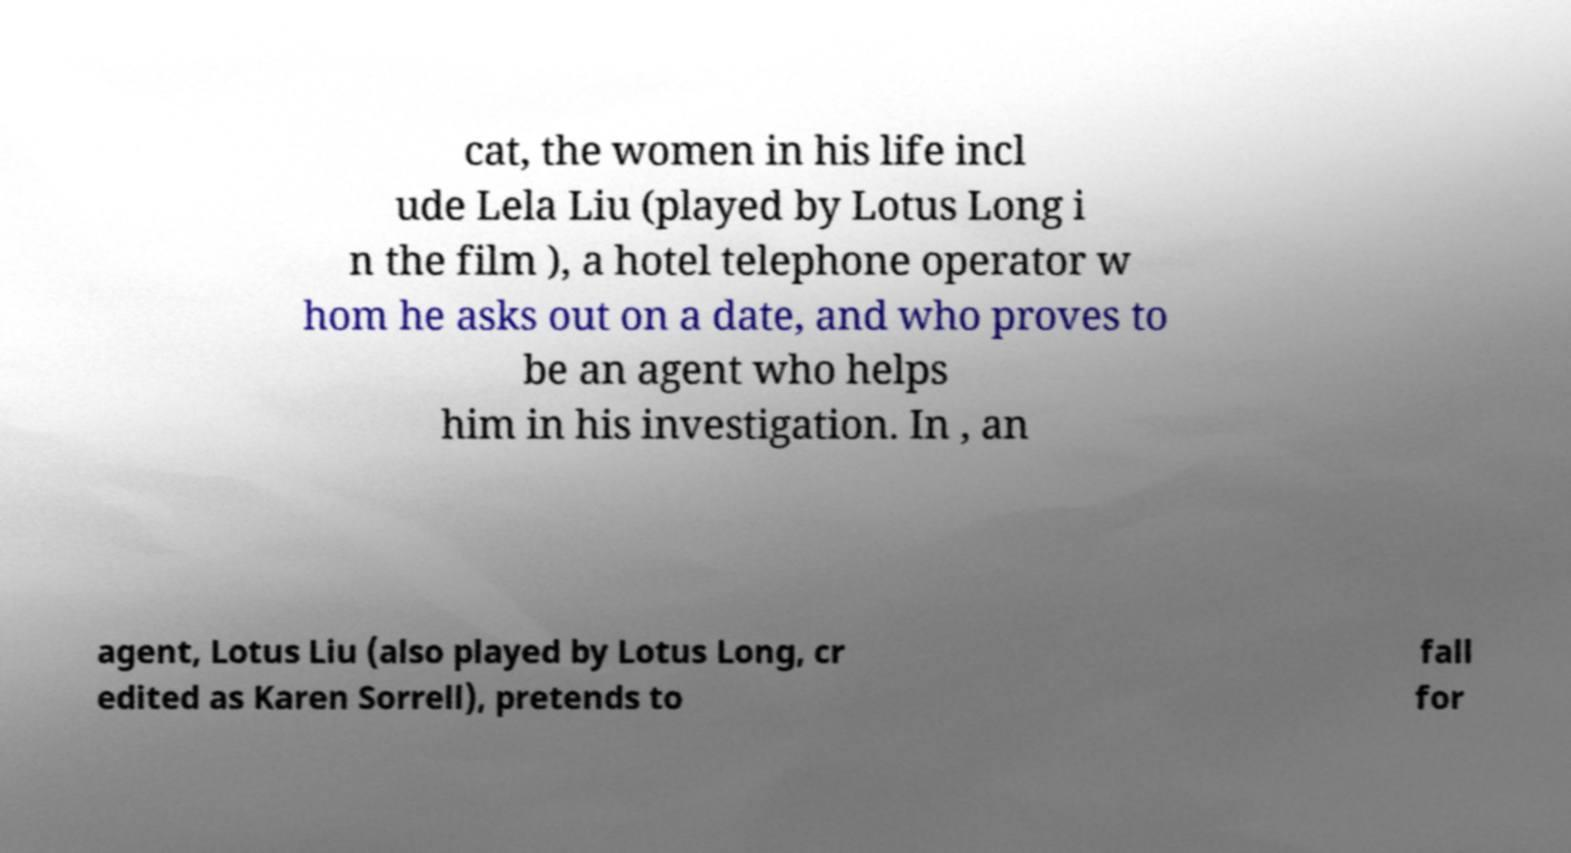Can you accurately transcribe the text from the provided image for me? cat, the women in his life incl ude Lela Liu (played by Lotus Long i n the film ), a hotel telephone operator w hom he asks out on a date, and who proves to be an agent who helps him in his investigation. In , an agent, Lotus Liu (also played by Lotus Long, cr edited as Karen Sorrell), pretends to fall for 